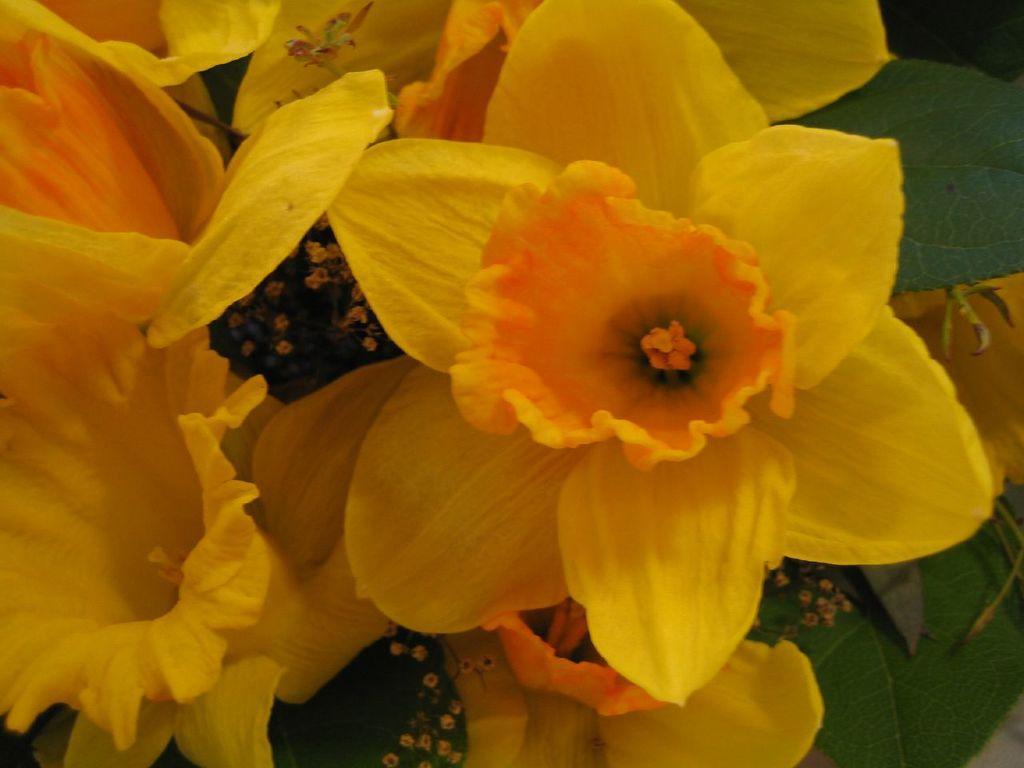Please provide a concise description of this image. In this image there are flowers and leaves. 